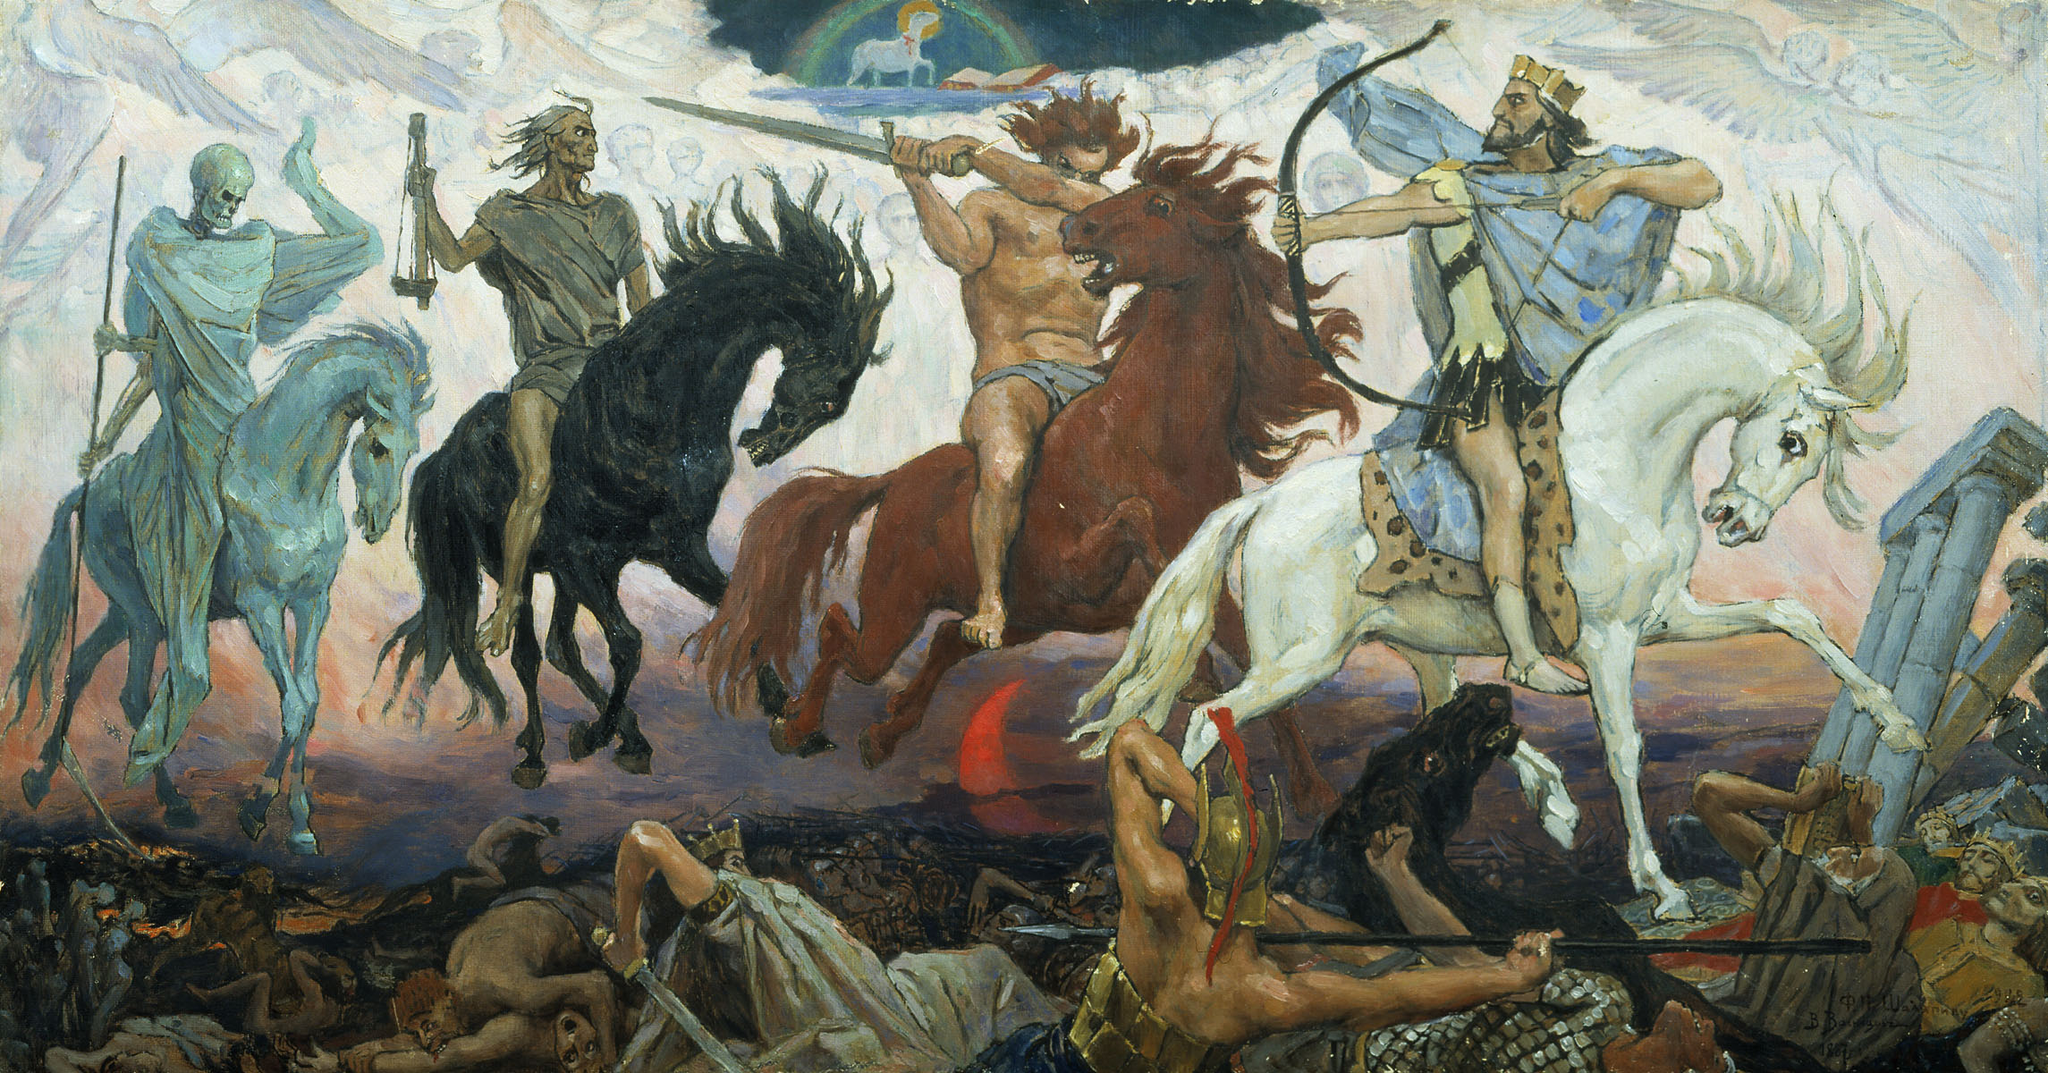What is the significance of the dynamic poses and expressions of the figures in this artwork? The dynamic poses and varied expressions captured in the artwork serve to convey the intense emotions and chaos inherent in battle. Each figure's pose, from the strained muscles of a warrior to the desperate clamber of a fallen soldier, enhances the feeling of motion and turmoil. This not only draws the viewer into the midst of the conflict but also communicates the psychological and physical impacts of war on individuals. The varied expressions, ranging from rage to fear, underline the personal and universal human experiences during such extreme events. 